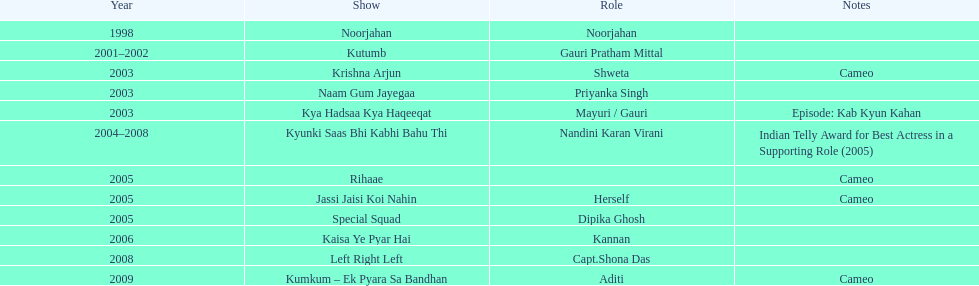How many different tv shows was gauri tejwani in before 2000? 1. Help me parse the entirety of this table. {'header': ['Year', 'Show', 'Role', 'Notes'], 'rows': [['1998', 'Noorjahan', 'Noorjahan', ''], ['2001–2002', 'Kutumb', 'Gauri Pratham Mittal', ''], ['2003', 'Krishna Arjun', 'Shweta', 'Cameo'], ['2003', 'Naam Gum Jayegaa', 'Priyanka Singh', ''], ['2003', 'Kya Hadsaa Kya Haqeeqat', 'Mayuri / Gauri', 'Episode: Kab Kyun Kahan'], ['2004–2008', 'Kyunki Saas Bhi Kabhi Bahu Thi', 'Nandini Karan Virani', 'Indian Telly Award for Best Actress in a Supporting Role (2005)'], ['2005', 'Rihaae', '', 'Cameo'], ['2005', 'Jassi Jaisi Koi Nahin', 'Herself', 'Cameo'], ['2005', 'Special Squad', 'Dipika Ghosh', ''], ['2006', 'Kaisa Ye Pyar Hai', 'Kannan', ''], ['2008', 'Left Right Left', 'Capt.Shona Das', ''], ['2009', 'Kumkum – Ek Pyara Sa Bandhan', 'Aditi', 'Cameo']]} 